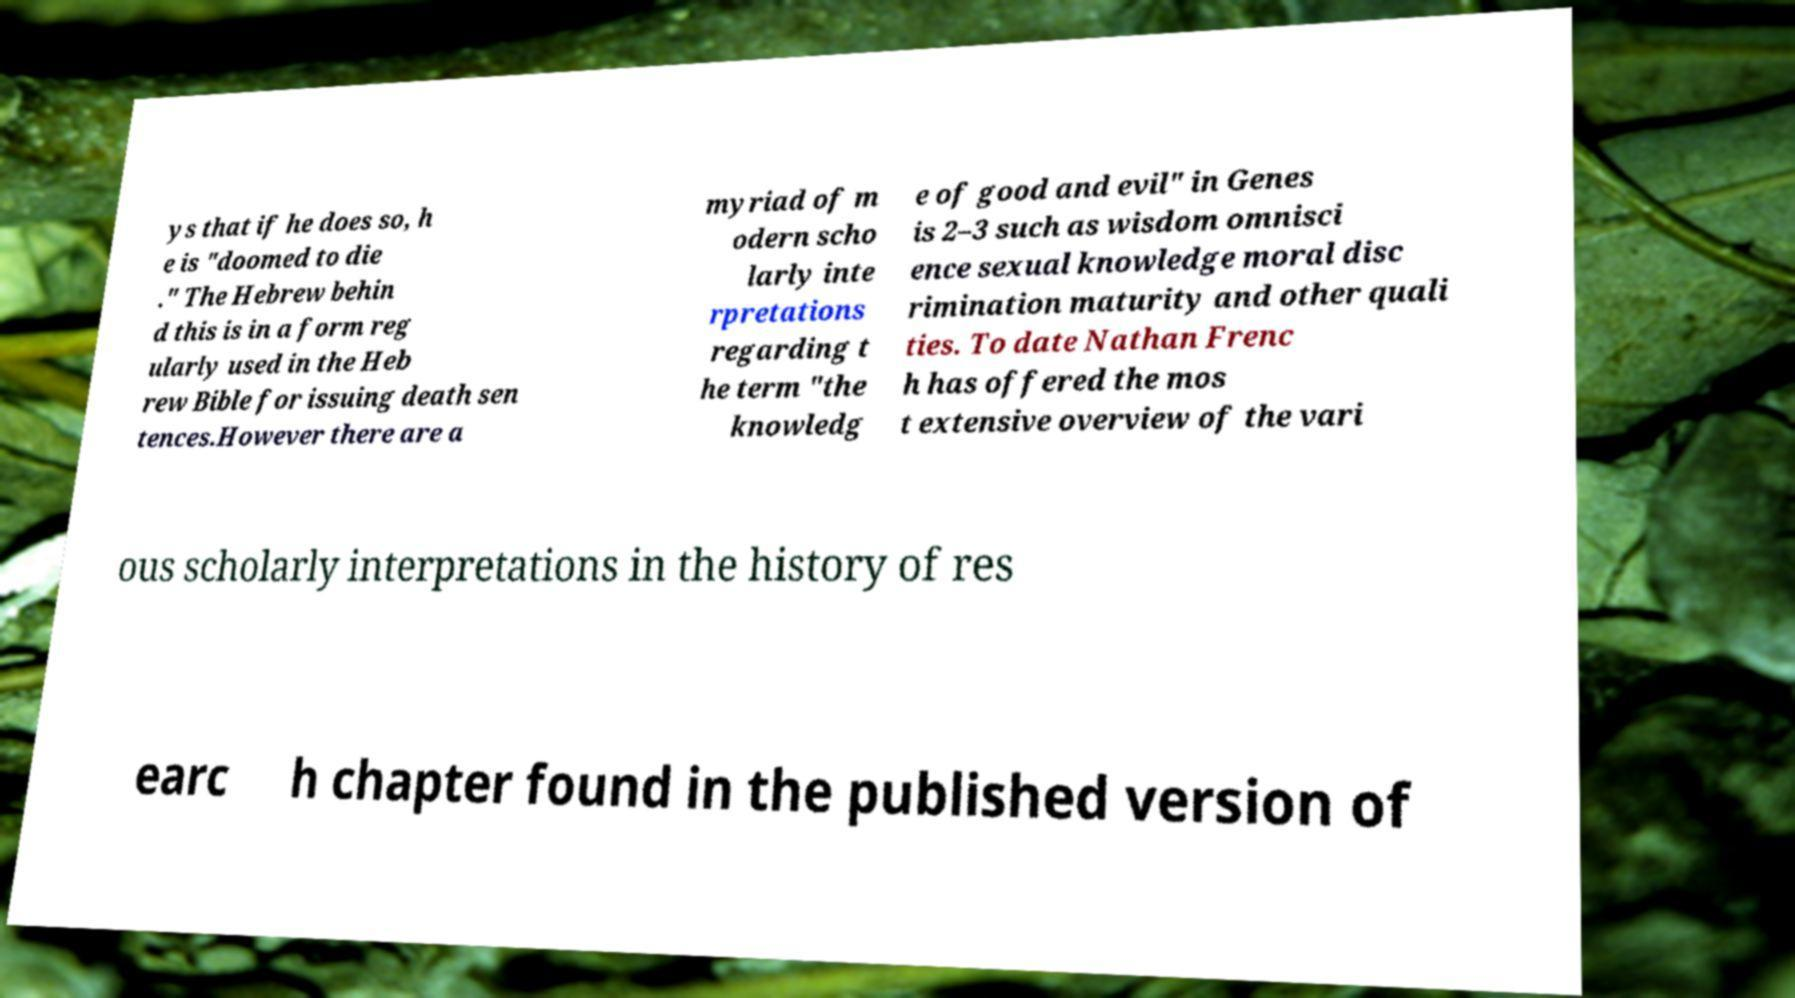Please read and relay the text visible in this image. What does it say? ys that if he does so, h e is "doomed to die ." The Hebrew behin d this is in a form reg ularly used in the Heb rew Bible for issuing death sen tences.However there are a myriad of m odern scho larly inte rpretations regarding t he term "the knowledg e of good and evil" in Genes is 2–3 such as wisdom omnisci ence sexual knowledge moral disc rimination maturity and other quali ties. To date Nathan Frenc h has offered the mos t extensive overview of the vari ous scholarly interpretations in the history of res earc h chapter found in the published version of 